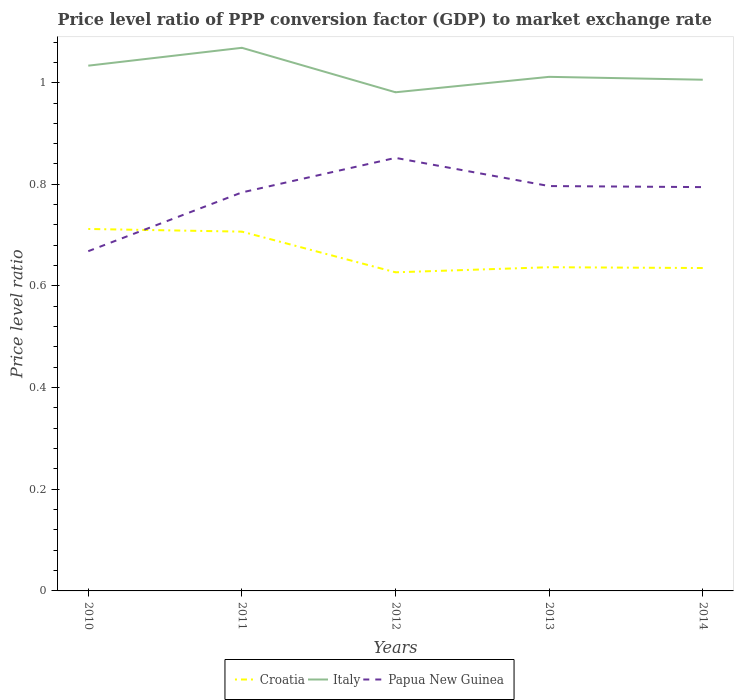How many different coloured lines are there?
Ensure brevity in your answer.  3. Is the number of lines equal to the number of legend labels?
Ensure brevity in your answer.  Yes. Across all years, what is the maximum price level ratio in Papua New Guinea?
Make the answer very short. 0.67. What is the total price level ratio in Croatia in the graph?
Provide a succinct answer. 0.09. What is the difference between the highest and the second highest price level ratio in Italy?
Your answer should be very brief. 0.09. How many years are there in the graph?
Provide a succinct answer. 5. What is the difference between two consecutive major ticks on the Y-axis?
Provide a succinct answer. 0.2. Are the values on the major ticks of Y-axis written in scientific E-notation?
Your answer should be very brief. No. Does the graph contain any zero values?
Your response must be concise. No. Where does the legend appear in the graph?
Your response must be concise. Bottom center. How many legend labels are there?
Your response must be concise. 3. How are the legend labels stacked?
Your answer should be very brief. Horizontal. What is the title of the graph?
Keep it short and to the point. Price level ratio of PPP conversion factor (GDP) to market exchange rate. What is the label or title of the X-axis?
Provide a short and direct response. Years. What is the label or title of the Y-axis?
Offer a very short reply. Price level ratio. What is the Price level ratio in Croatia in 2010?
Provide a short and direct response. 0.71. What is the Price level ratio of Italy in 2010?
Provide a short and direct response. 1.03. What is the Price level ratio in Papua New Guinea in 2010?
Ensure brevity in your answer.  0.67. What is the Price level ratio of Croatia in 2011?
Your response must be concise. 0.71. What is the Price level ratio of Italy in 2011?
Your answer should be compact. 1.07. What is the Price level ratio of Papua New Guinea in 2011?
Your answer should be very brief. 0.78. What is the Price level ratio in Croatia in 2012?
Offer a terse response. 0.63. What is the Price level ratio of Italy in 2012?
Make the answer very short. 0.98. What is the Price level ratio in Papua New Guinea in 2012?
Your answer should be compact. 0.85. What is the Price level ratio of Croatia in 2013?
Offer a very short reply. 0.64. What is the Price level ratio of Italy in 2013?
Provide a succinct answer. 1.01. What is the Price level ratio of Papua New Guinea in 2013?
Your answer should be compact. 0.8. What is the Price level ratio in Croatia in 2014?
Offer a terse response. 0.64. What is the Price level ratio of Italy in 2014?
Provide a short and direct response. 1.01. What is the Price level ratio in Papua New Guinea in 2014?
Your response must be concise. 0.79. Across all years, what is the maximum Price level ratio of Croatia?
Your response must be concise. 0.71. Across all years, what is the maximum Price level ratio of Italy?
Provide a succinct answer. 1.07. Across all years, what is the maximum Price level ratio in Papua New Guinea?
Offer a very short reply. 0.85. Across all years, what is the minimum Price level ratio in Croatia?
Make the answer very short. 0.63. Across all years, what is the minimum Price level ratio in Italy?
Offer a terse response. 0.98. Across all years, what is the minimum Price level ratio in Papua New Guinea?
Provide a short and direct response. 0.67. What is the total Price level ratio in Croatia in the graph?
Keep it short and to the point. 3.32. What is the total Price level ratio of Italy in the graph?
Your response must be concise. 5.1. What is the total Price level ratio of Papua New Guinea in the graph?
Your answer should be very brief. 3.9. What is the difference between the Price level ratio of Croatia in 2010 and that in 2011?
Ensure brevity in your answer.  0.01. What is the difference between the Price level ratio in Italy in 2010 and that in 2011?
Keep it short and to the point. -0.04. What is the difference between the Price level ratio of Papua New Guinea in 2010 and that in 2011?
Provide a succinct answer. -0.12. What is the difference between the Price level ratio of Croatia in 2010 and that in 2012?
Provide a succinct answer. 0.09. What is the difference between the Price level ratio of Italy in 2010 and that in 2012?
Give a very brief answer. 0.05. What is the difference between the Price level ratio of Papua New Guinea in 2010 and that in 2012?
Provide a succinct answer. -0.18. What is the difference between the Price level ratio in Croatia in 2010 and that in 2013?
Offer a terse response. 0.08. What is the difference between the Price level ratio in Italy in 2010 and that in 2013?
Offer a very short reply. 0.02. What is the difference between the Price level ratio in Papua New Guinea in 2010 and that in 2013?
Give a very brief answer. -0.13. What is the difference between the Price level ratio of Croatia in 2010 and that in 2014?
Your answer should be very brief. 0.08. What is the difference between the Price level ratio of Italy in 2010 and that in 2014?
Offer a very short reply. 0.03. What is the difference between the Price level ratio in Papua New Guinea in 2010 and that in 2014?
Your answer should be very brief. -0.13. What is the difference between the Price level ratio in Italy in 2011 and that in 2012?
Offer a terse response. 0.09. What is the difference between the Price level ratio in Papua New Guinea in 2011 and that in 2012?
Offer a very short reply. -0.07. What is the difference between the Price level ratio in Croatia in 2011 and that in 2013?
Offer a very short reply. 0.07. What is the difference between the Price level ratio in Italy in 2011 and that in 2013?
Provide a short and direct response. 0.06. What is the difference between the Price level ratio in Papua New Guinea in 2011 and that in 2013?
Your response must be concise. -0.01. What is the difference between the Price level ratio of Croatia in 2011 and that in 2014?
Provide a succinct answer. 0.07. What is the difference between the Price level ratio of Italy in 2011 and that in 2014?
Offer a terse response. 0.06. What is the difference between the Price level ratio in Papua New Guinea in 2011 and that in 2014?
Your answer should be very brief. -0.01. What is the difference between the Price level ratio in Croatia in 2012 and that in 2013?
Provide a short and direct response. -0.01. What is the difference between the Price level ratio in Italy in 2012 and that in 2013?
Keep it short and to the point. -0.03. What is the difference between the Price level ratio of Papua New Guinea in 2012 and that in 2013?
Provide a short and direct response. 0.06. What is the difference between the Price level ratio of Croatia in 2012 and that in 2014?
Provide a succinct answer. -0.01. What is the difference between the Price level ratio of Italy in 2012 and that in 2014?
Your response must be concise. -0.02. What is the difference between the Price level ratio of Papua New Guinea in 2012 and that in 2014?
Your answer should be compact. 0.06. What is the difference between the Price level ratio of Croatia in 2013 and that in 2014?
Your response must be concise. 0. What is the difference between the Price level ratio of Italy in 2013 and that in 2014?
Keep it short and to the point. 0.01. What is the difference between the Price level ratio in Papua New Guinea in 2013 and that in 2014?
Your answer should be very brief. 0. What is the difference between the Price level ratio in Croatia in 2010 and the Price level ratio in Italy in 2011?
Make the answer very short. -0.36. What is the difference between the Price level ratio of Croatia in 2010 and the Price level ratio of Papua New Guinea in 2011?
Provide a succinct answer. -0.07. What is the difference between the Price level ratio of Italy in 2010 and the Price level ratio of Papua New Guinea in 2011?
Your answer should be compact. 0.25. What is the difference between the Price level ratio of Croatia in 2010 and the Price level ratio of Italy in 2012?
Your answer should be very brief. -0.27. What is the difference between the Price level ratio in Croatia in 2010 and the Price level ratio in Papua New Guinea in 2012?
Give a very brief answer. -0.14. What is the difference between the Price level ratio in Italy in 2010 and the Price level ratio in Papua New Guinea in 2012?
Offer a very short reply. 0.18. What is the difference between the Price level ratio of Croatia in 2010 and the Price level ratio of Italy in 2013?
Your response must be concise. -0.3. What is the difference between the Price level ratio in Croatia in 2010 and the Price level ratio in Papua New Guinea in 2013?
Your answer should be compact. -0.08. What is the difference between the Price level ratio of Italy in 2010 and the Price level ratio of Papua New Guinea in 2013?
Keep it short and to the point. 0.24. What is the difference between the Price level ratio in Croatia in 2010 and the Price level ratio in Italy in 2014?
Ensure brevity in your answer.  -0.29. What is the difference between the Price level ratio in Croatia in 2010 and the Price level ratio in Papua New Guinea in 2014?
Keep it short and to the point. -0.08. What is the difference between the Price level ratio in Italy in 2010 and the Price level ratio in Papua New Guinea in 2014?
Give a very brief answer. 0.24. What is the difference between the Price level ratio of Croatia in 2011 and the Price level ratio of Italy in 2012?
Provide a succinct answer. -0.27. What is the difference between the Price level ratio in Croatia in 2011 and the Price level ratio in Papua New Guinea in 2012?
Offer a terse response. -0.15. What is the difference between the Price level ratio of Italy in 2011 and the Price level ratio of Papua New Guinea in 2012?
Ensure brevity in your answer.  0.22. What is the difference between the Price level ratio of Croatia in 2011 and the Price level ratio of Italy in 2013?
Ensure brevity in your answer.  -0.3. What is the difference between the Price level ratio in Croatia in 2011 and the Price level ratio in Papua New Guinea in 2013?
Your answer should be very brief. -0.09. What is the difference between the Price level ratio in Italy in 2011 and the Price level ratio in Papua New Guinea in 2013?
Your response must be concise. 0.27. What is the difference between the Price level ratio in Croatia in 2011 and the Price level ratio in Italy in 2014?
Provide a short and direct response. -0.3. What is the difference between the Price level ratio of Croatia in 2011 and the Price level ratio of Papua New Guinea in 2014?
Make the answer very short. -0.09. What is the difference between the Price level ratio of Italy in 2011 and the Price level ratio of Papua New Guinea in 2014?
Ensure brevity in your answer.  0.27. What is the difference between the Price level ratio of Croatia in 2012 and the Price level ratio of Italy in 2013?
Offer a terse response. -0.38. What is the difference between the Price level ratio in Croatia in 2012 and the Price level ratio in Papua New Guinea in 2013?
Your answer should be very brief. -0.17. What is the difference between the Price level ratio in Italy in 2012 and the Price level ratio in Papua New Guinea in 2013?
Your answer should be very brief. 0.18. What is the difference between the Price level ratio of Croatia in 2012 and the Price level ratio of Italy in 2014?
Your response must be concise. -0.38. What is the difference between the Price level ratio of Croatia in 2012 and the Price level ratio of Papua New Guinea in 2014?
Offer a very short reply. -0.17. What is the difference between the Price level ratio in Italy in 2012 and the Price level ratio in Papua New Guinea in 2014?
Your response must be concise. 0.19. What is the difference between the Price level ratio in Croatia in 2013 and the Price level ratio in Italy in 2014?
Provide a short and direct response. -0.37. What is the difference between the Price level ratio of Croatia in 2013 and the Price level ratio of Papua New Guinea in 2014?
Provide a succinct answer. -0.16. What is the difference between the Price level ratio of Italy in 2013 and the Price level ratio of Papua New Guinea in 2014?
Keep it short and to the point. 0.22. What is the average Price level ratio of Croatia per year?
Provide a succinct answer. 0.66. What is the average Price level ratio in Italy per year?
Your answer should be compact. 1.02. What is the average Price level ratio of Papua New Guinea per year?
Your response must be concise. 0.78. In the year 2010, what is the difference between the Price level ratio in Croatia and Price level ratio in Italy?
Your answer should be very brief. -0.32. In the year 2010, what is the difference between the Price level ratio in Croatia and Price level ratio in Papua New Guinea?
Make the answer very short. 0.04. In the year 2010, what is the difference between the Price level ratio in Italy and Price level ratio in Papua New Guinea?
Offer a very short reply. 0.36. In the year 2011, what is the difference between the Price level ratio in Croatia and Price level ratio in Italy?
Offer a very short reply. -0.36. In the year 2011, what is the difference between the Price level ratio in Croatia and Price level ratio in Papua New Guinea?
Keep it short and to the point. -0.08. In the year 2011, what is the difference between the Price level ratio in Italy and Price level ratio in Papua New Guinea?
Your answer should be compact. 0.28. In the year 2012, what is the difference between the Price level ratio of Croatia and Price level ratio of Italy?
Provide a succinct answer. -0.35. In the year 2012, what is the difference between the Price level ratio in Croatia and Price level ratio in Papua New Guinea?
Keep it short and to the point. -0.23. In the year 2012, what is the difference between the Price level ratio of Italy and Price level ratio of Papua New Guinea?
Offer a very short reply. 0.13. In the year 2013, what is the difference between the Price level ratio of Croatia and Price level ratio of Italy?
Your response must be concise. -0.37. In the year 2013, what is the difference between the Price level ratio of Croatia and Price level ratio of Papua New Guinea?
Offer a very short reply. -0.16. In the year 2013, what is the difference between the Price level ratio in Italy and Price level ratio in Papua New Guinea?
Ensure brevity in your answer.  0.21. In the year 2014, what is the difference between the Price level ratio in Croatia and Price level ratio in Italy?
Your response must be concise. -0.37. In the year 2014, what is the difference between the Price level ratio in Croatia and Price level ratio in Papua New Guinea?
Your answer should be compact. -0.16. In the year 2014, what is the difference between the Price level ratio in Italy and Price level ratio in Papua New Guinea?
Offer a very short reply. 0.21. What is the ratio of the Price level ratio of Croatia in 2010 to that in 2011?
Keep it short and to the point. 1.01. What is the ratio of the Price level ratio in Italy in 2010 to that in 2011?
Offer a terse response. 0.97. What is the ratio of the Price level ratio of Papua New Guinea in 2010 to that in 2011?
Offer a very short reply. 0.85. What is the ratio of the Price level ratio of Croatia in 2010 to that in 2012?
Ensure brevity in your answer.  1.14. What is the ratio of the Price level ratio of Italy in 2010 to that in 2012?
Ensure brevity in your answer.  1.05. What is the ratio of the Price level ratio in Papua New Guinea in 2010 to that in 2012?
Ensure brevity in your answer.  0.78. What is the ratio of the Price level ratio of Croatia in 2010 to that in 2013?
Make the answer very short. 1.12. What is the ratio of the Price level ratio in Italy in 2010 to that in 2013?
Your answer should be compact. 1.02. What is the ratio of the Price level ratio of Papua New Guinea in 2010 to that in 2013?
Keep it short and to the point. 0.84. What is the ratio of the Price level ratio of Croatia in 2010 to that in 2014?
Provide a succinct answer. 1.12. What is the ratio of the Price level ratio of Italy in 2010 to that in 2014?
Provide a succinct answer. 1.03. What is the ratio of the Price level ratio of Papua New Guinea in 2010 to that in 2014?
Ensure brevity in your answer.  0.84. What is the ratio of the Price level ratio of Croatia in 2011 to that in 2012?
Ensure brevity in your answer.  1.13. What is the ratio of the Price level ratio in Italy in 2011 to that in 2012?
Your answer should be very brief. 1.09. What is the ratio of the Price level ratio of Papua New Guinea in 2011 to that in 2012?
Your response must be concise. 0.92. What is the ratio of the Price level ratio in Croatia in 2011 to that in 2013?
Keep it short and to the point. 1.11. What is the ratio of the Price level ratio in Italy in 2011 to that in 2013?
Offer a terse response. 1.06. What is the ratio of the Price level ratio in Papua New Guinea in 2011 to that in 2013?
Offer a terse response. 0.98. What is the ratio of the Price level ratio of Croatia in 2011 to that in 2014?
Your answer should be very brief. 1.11. What is the ratio of the Price level ratio of Italy in 2011 to that in 2014?
Ensure brevity in your answer.  1.06. What is the ratio of the Price level ratio of Croatia in 2012 to that in 2013?
Make the answer very short. 0.98. What is the ratio of the Price level ratio in Papua New Guinea in 2012 to that in 2013?
Offer a terse response. 1.07. What is the ratio of the Price level ratio of Croatia in 2012 to that in 2014?
Give a very brief answer. 0.99. What is the ratio of the Price level ratio of Italy in 2012 to that in 2014?
Provide a succinct answer. 0.98. What is the ratio of the Price level ratio of Papua New Guinea in 2012 to that in 2014?
Give a very brief answer. 1.07. What is the ratio of the Price level ratio of Croatia in 2013 to that in 2014?
Provide a short and direct response. 1. What is the ratio of the Price level ratio of Italy in 2013 to that in 2014?
Make the answer very short. 1.01. What is the difference between the highest and the second highest Price level ratio of Croatia?
Offer a very short reply. 0.01. What is the difference between the highest and the second highest Price level ratio of Italy?
Provide a short and direct response. 0.04. What is the difference between the highest and the second highest Price level ratio of Papua New Guinea?
Provide a succinct answer. 0.06. What is the difference between the highest and the lowest Price level ratio in Croatia?
Give a very brief answer. 0.09. What is the difference between the highest and the lowest Price level ratio in Italy?
Provide a succinct answer. 0.09. What is the difference between the highest and the lowest Price level ratio in Papua New Guinea?
Provide a succinct answer. 0.18. 